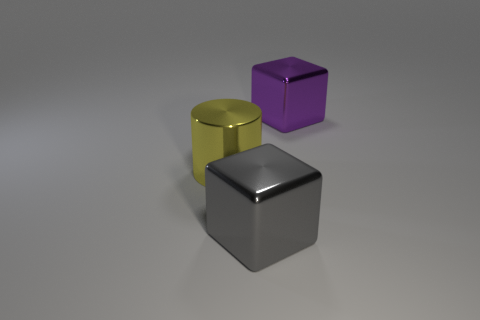The yellow metallic thing is what shape?
Your answer should be compact. Cylinder. What color is the large cube that is made of the same material as the big purple thing?
Ensure brevity in your answer.  Gray. How many blue objects are either large metal blocks or small cubes?
Provide a succinct answer. 0. Is the number of large metal blocks greater than the number of small brown balls?
Provide a short and direct response. Yes. What number of objects are either big shiny cubes that are in front of the yellow thing or blocks in front of the yellow metallic cylinder?
Make the answer very short. 1. There is a metal cylinder that is the same size as the gray object; what is its color?
Provide a succinct answer. Yellow. Does the big cylinder have the same material as the big purple object?
Offer a terse response. Yes. What material is the large cube in front of the metal object that is on the right side of the large gray shiny block?
Give a very brief answer. Metal. Is the number of gray metallic things behind the purple cube greater than the number of small things?
Offer a very short reply. No. There is a big shiny cylinder on the left side of the shiny cube in front of the big purple thing behind the yellow metal thing; what is its color?
Ensure brevity in your answer.  Yellow. 